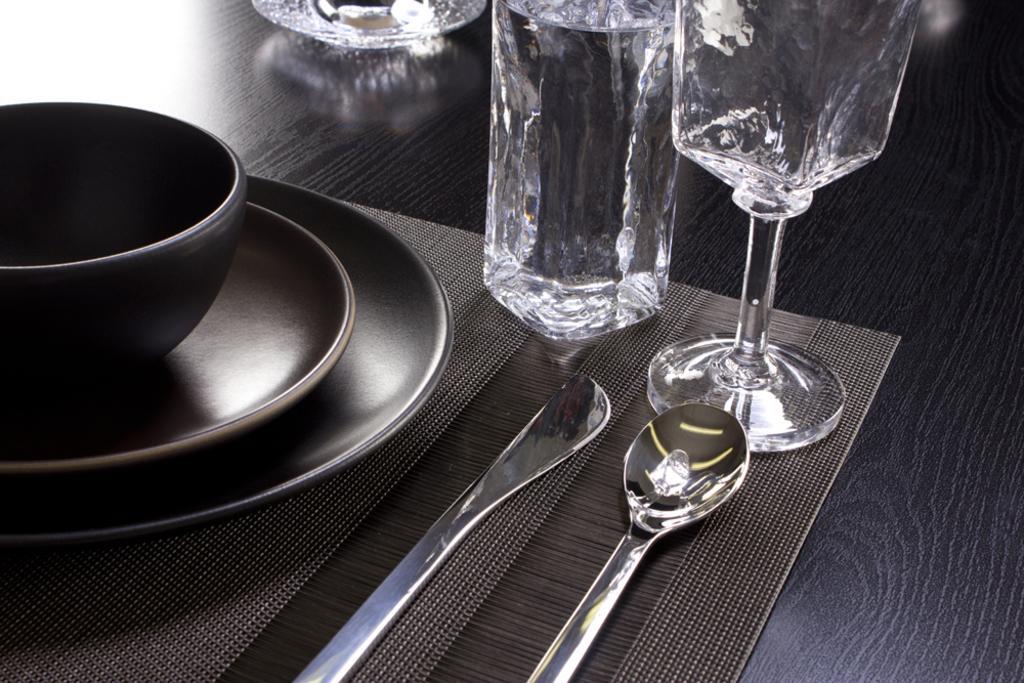In one or two sentences, can you explain what this image depicts? Here we can see that a glasses and spoons and bowls, and plates on the table, and some other objects on it. 